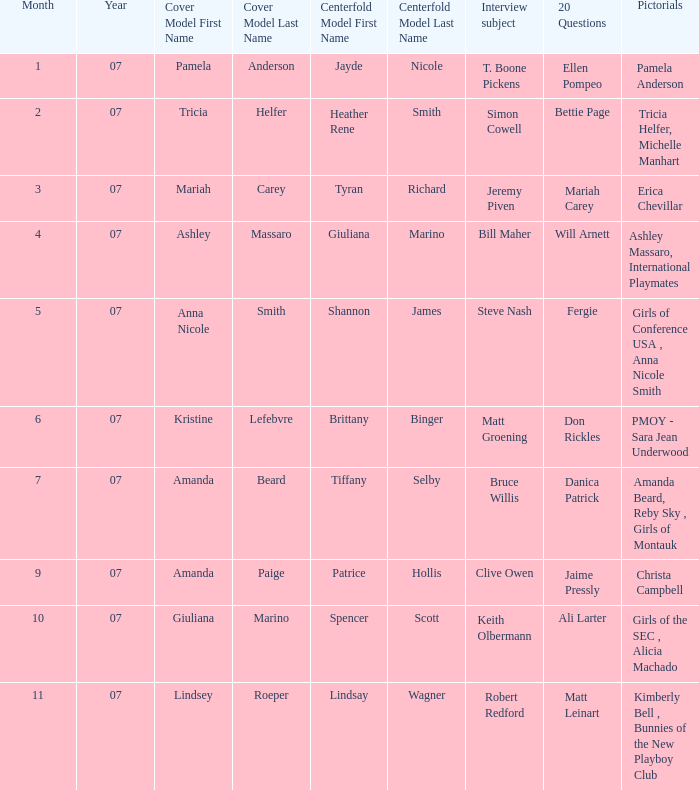Who was the cover model when the issue's pictorials was pmoy - sara jean underwood? Kristine Lefebvre. 